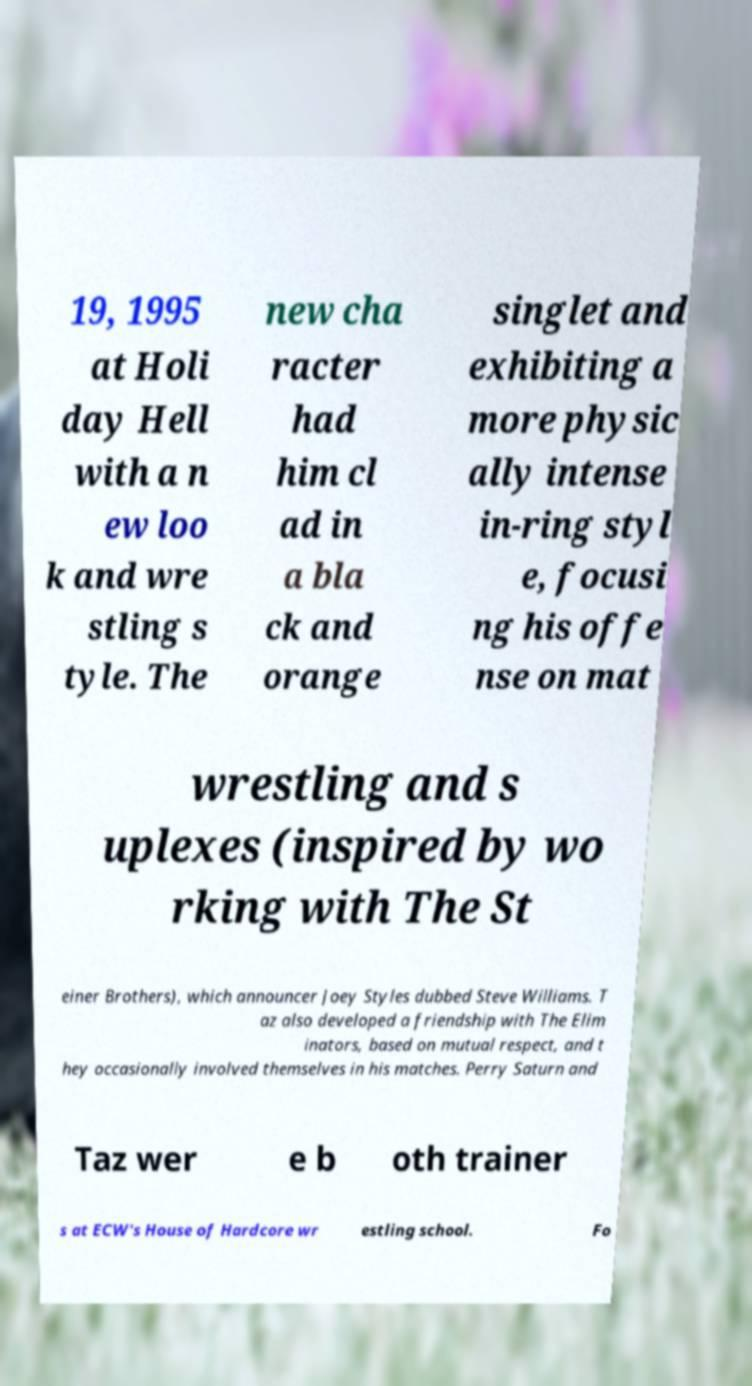Please identify and transcribe the text found in this image. 19, 1995 at Holi day Hell with a n ew loo k and wre stling s tyle. The new cha racter had him cl ad in a bla ck and orange singlet and exhibiting a more physic ally intense in-ring styl e, focusi ng his offe nse on mat wrestling and s uplexes (inspired by wo rking with The St einer Brothers), which announcer Joey Styles dubbed Steve Williams. T az also developed a friendship with The Elim inators, based on mutual respect, and t hey occasionally involved themselves in his matches. Perry Saturn and Taz wer e b oth trainer s at ECW's House of Hardcore wr estling school. Fo 